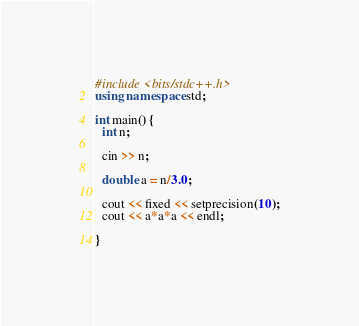<code> <loc_0><loc_0><loc_500><loc_500><_C++_>#include <bits/stdc++.h>
using namespace std;

int main() {
  int n;

  cin >> n;
  
  double a = n/3.0;
  
  cout << fixed << setprecision(10);
  cout << a*a*a << endl;
  
}
</code> 